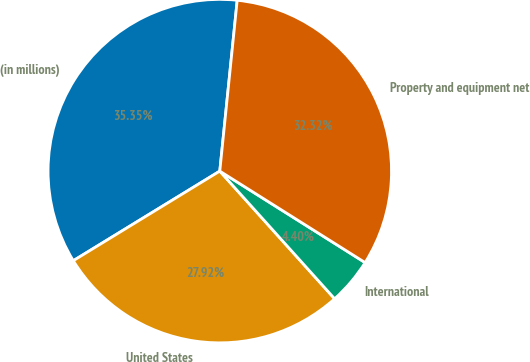<chart> <loc_0><loc_0><loc_500><loc_500><pie_chart><fcel>(in millions)<fcel>United States<fcel>International<fcel>Property and equipment net<nl><fcel>35.35%<fcel>27.92%<fcel>4.4%<fcel>32.32%<nl></chart> 